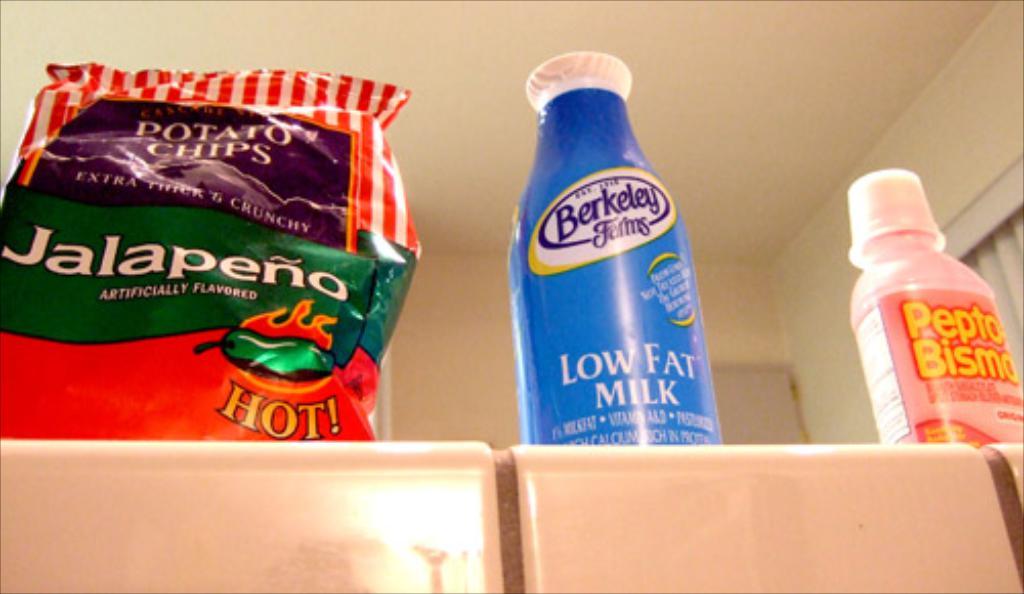What flavor are the potato chips?
Your response must be concise. Jalapeno. What type of milk is it?
Give a very brief answer. Low fat. 